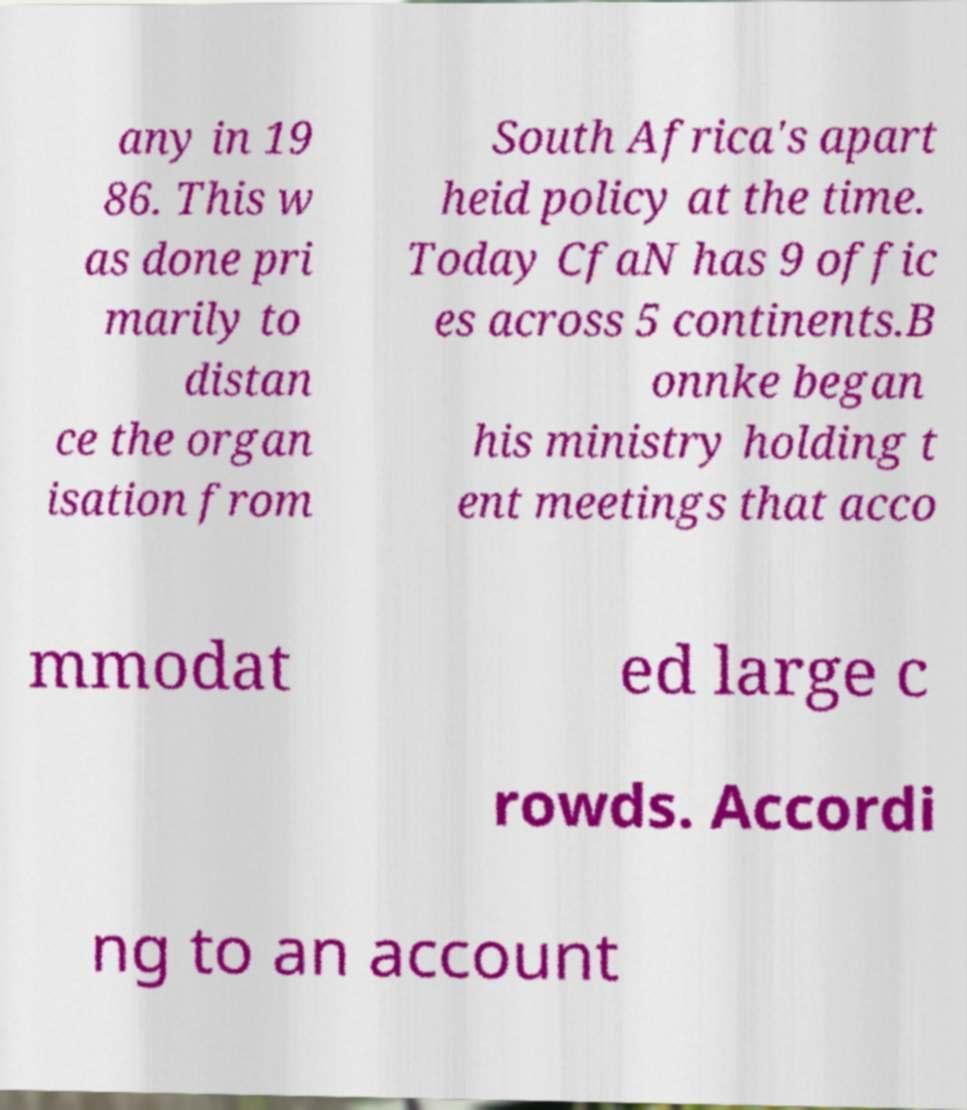What messages or text are displayed in this image? I need them in a readable, typed format. any in 19 86. This w as done pri marily to distan ce the organ isation from South Africa's apart heid policy at the time. Today CfaN has 9 offic es across 5 continents.B onnke began his ministry holding t ent meetings that acco mmodat ed large c rowds. Accordi ng to an account 